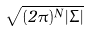<formula> <loc_0><loc_0><loc_500><loc_500>\sqrt { ( 2 \pi ) ^ { N } | \Sigma | }</formula> 